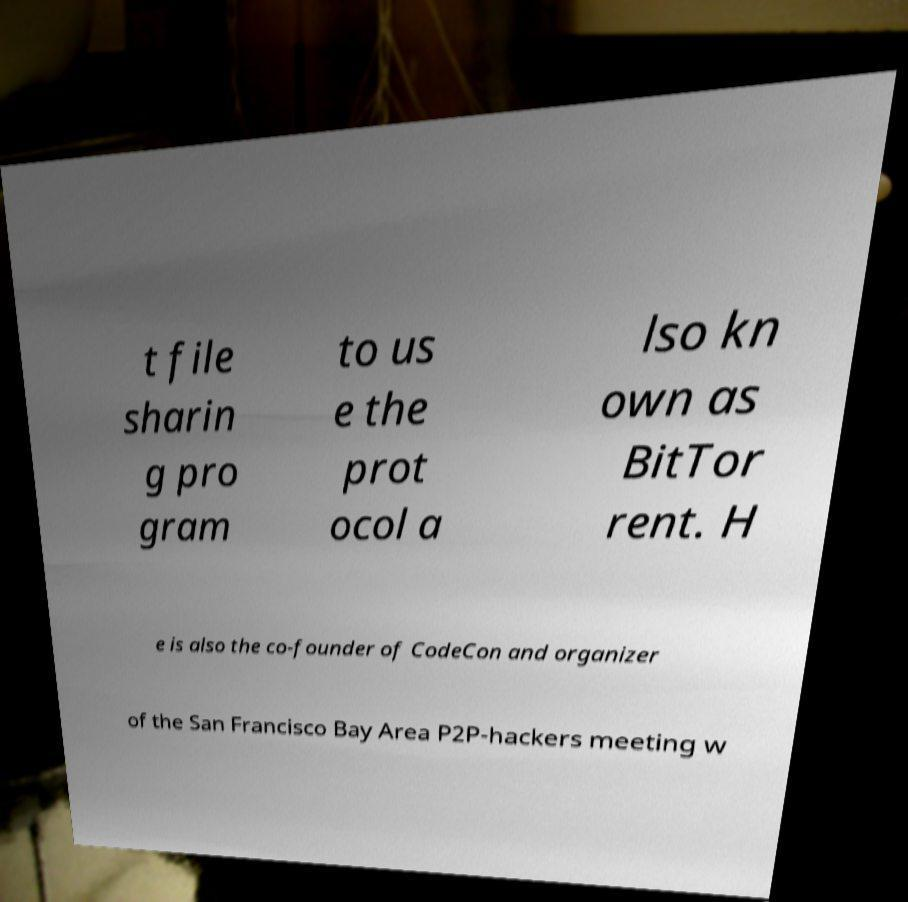What messages or text are displayed in this image? I need them in a readable, typed format. t file sharin g pro gram to us e the prot ocol a lso kn own as BitTor rent. H e is also the co-founder of CodeCon and organizer of the San Francisco Bay Area P2P-hackers meeting w 